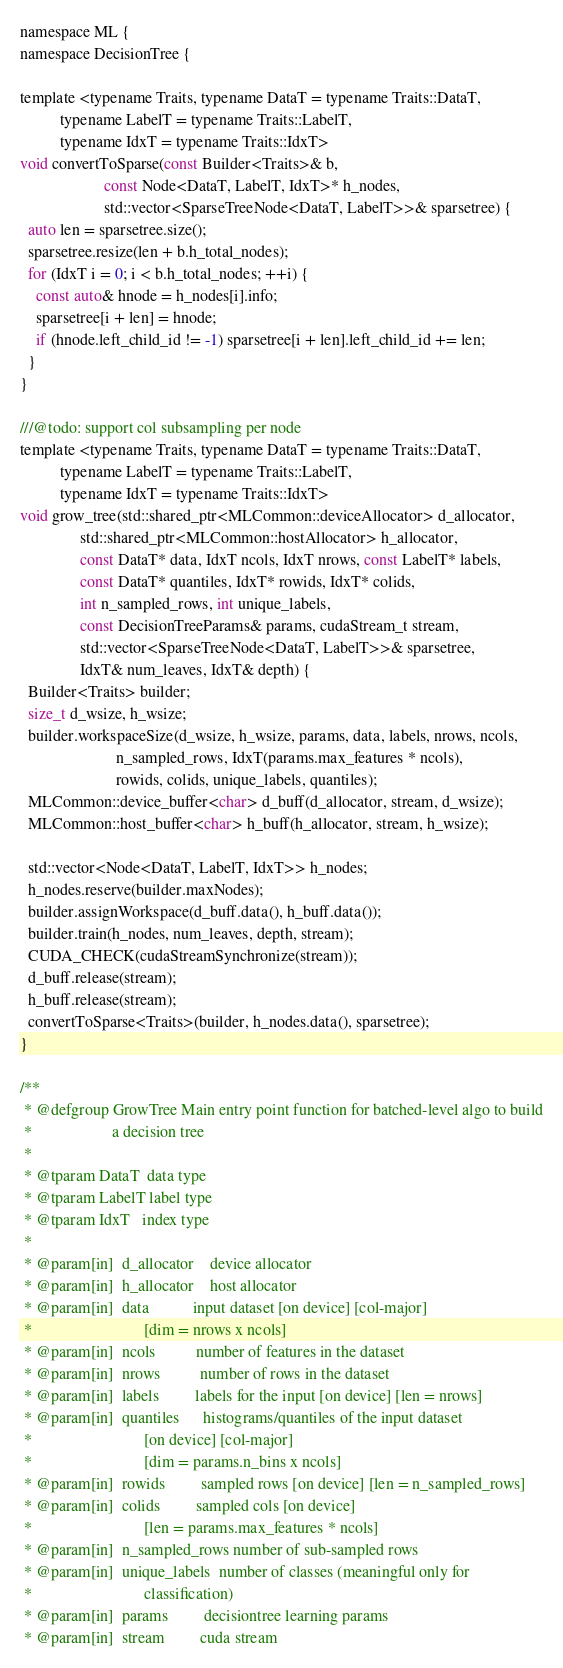Convert code to text. <code><loc_0><loc_0><loc_500><loc_500><_Cuda_>namespace ML {
namespace DecisionTree {

template <typename Traits, typename DataT = typename Traits::DataT,
          typename LabelT = typename Traits::LabelT,
          typename IdxT = typename Traits::IdxT>
void convertToSparse(const Builder<Traits>& b,
                     const Node<DataT, LabelT, IdxT>* h_nodes,
                     std::vector<SparseTreeNode<DataT, LabelT>>& sparsetree) {
  auto len = sparsetree.size();
  sparsetree.resize(len + b.h_total_nodes);
  for (IdxT i = 0; i < b.h_total_nodes; ++i) {
    const auto& hnode = h_nodes[i].info;
    sparsetree[i + len] = hnode;
    if (hnode.left_child_id != -1) sparsetree[i + len].left_child_id += len;
  }
}

///@todo: support col subsampling per node
template <typename Traits, typename DataT = typename Traits::DataT,
          typename LabelT = typename Traits::LabelT,
          typename IdxT = typename Traits::IdxT>
void grow_tree(std::shared_ptr<MLCommon::deviceAllocator> d_allocator,
               std::shared_ptr<MLCommon::hostAllocator> h_allocator,
               const DataT* data, IdxT ncols, IdxT nrows, const LabelT* labels,
               const DataT* quantiles, IdxT* rowids, IdxT* colids,
               int n_sampled_rows, int unique_labels,
               const DecisionTreeParams& params, cudaStream_t stream,
               std::vector<SparseTreeNode<DataT, LabelT>>& sparsetree,
               IdxT& num_leaves, IdxT& depth) {
  Builder<Traits> builder;
  size_t d_wsize, h_wsize;
  builder.workspaceSize(d_wsize, h_wsize, params, data, labels, nrows, ncols,
                        n_sampled_rows, IdxT(params.max_features * ncols),
                        rowids, colids, unique_labels, quantiles);
  MLCommon::device_buffer<char> d_buff(d_allocator, stream, d_wsize);
  MLCommon::host_buffer<char> h_buff(h_allocator, stream, h_wsize);

  std::vector<Node<DataT, LabelT, IdxT>> h_nodes;
  h_nodes.reserve(builder.maxNodes);
  builder.assignWorkspace(d_buff.data(), h_buff.data());
  builder.train(h_nodes, num_leaves, depth, stream);
  CUDA_CHECK(cudaStreamSynchronize(stream));
  d_buff.release(stream);
  h_buff.release(stream);
  convertToSparse<Traits>(builder, h_nodes.data(), sparsetree);
}

/**
 * @defgroup GrowTree Main entry point function for batched-level algo to build
 *                    a decision tree
 *
 * @tparam DataT  data type
 * @tparam LabelT label type
 * @tparam IdxT   index type
 *
 * @param[in]  d_allocator    device allocator
 * @param[in]  h_allocator    host allocator
 * @param[in]  data           input dataset [on device] [col-major]
 *                            [dim = nrows x ncols]
 * @param[in]  ncols          number of features in the dataset
 * @param[in]  nrows          number of rows in the dataset
 * @param[in]  labels         labels for the input [on device] [len = nrows]
 * @param[in]  quantiles      histograms/quantiles of the input dataset
 *                            [on device] [col-major]
 *                            [dim = params.n_bins x ncols]
 * @param[in]  rowids         sampled rows [on device] [len = n_sampled_rows]
 * @param[in]  colids         sampled cols [on device]
 *                            [len = params.max_features * ncols]
 * @param[in]  n_sampled_rows number of sub-sampled rows
 * @param[in]  unique_labels  number of classes (meaningful only for
 *                            classification)
 * @param[in]  params         decisiontree learning params
 * @param[in]  stream         cuda stream</code> 